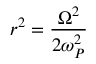Convert formula to latex. <formula><loc_0><loc_0><loc_500><loc_500>r ^ { 2 } = \frac { \Omega ^ { 2 } } { 2 \omega _ { P } ^ { 2 } }</formula> 